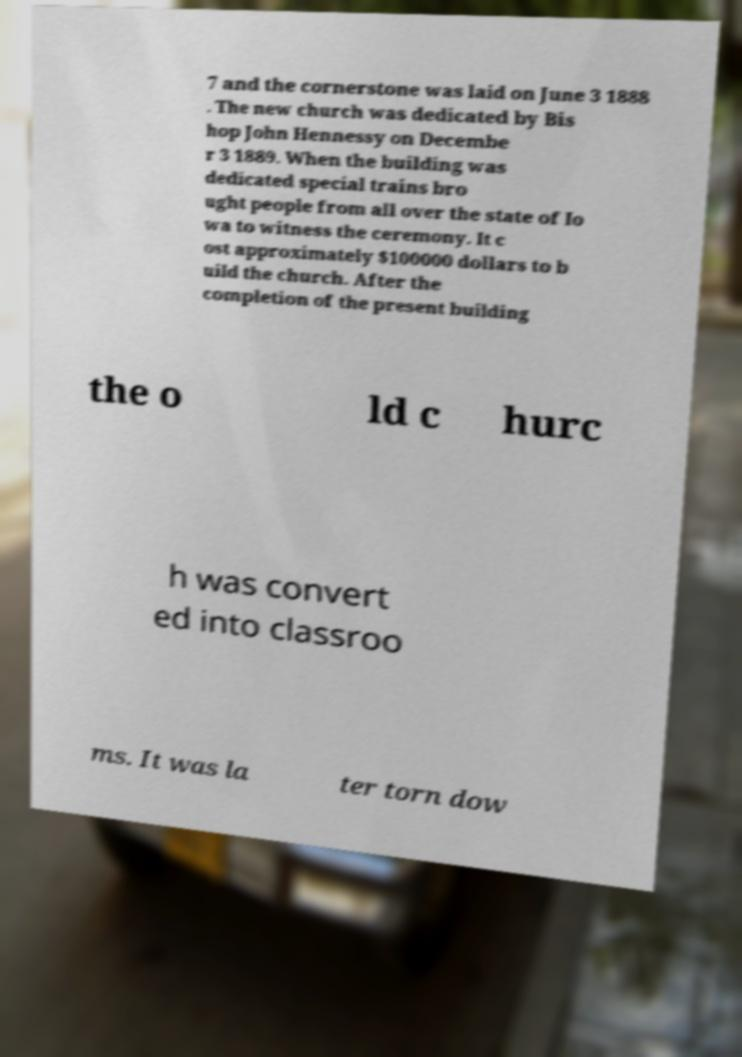Could you extract and type out the text from this image? 7 and the cornerstone was laid on June 3 1888 . The new church was dedicated by Bis hop John Hennessy on Decembe r 3 1889. When the building was dedicated special trains bro ught people from all over the state of Io wa to witness the ceremony. It c ost approximately $100000 dollars to b uild the church. After the completion of the present building the o ld c hurc h was convert ed into classroo ms. It was la ter torn dow 